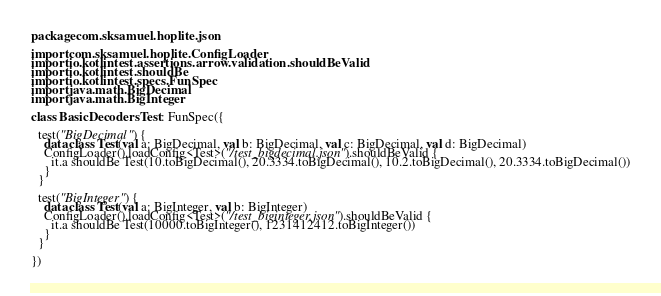Convert code to text. <code><loc_0><loc_0><loc_500><loc_500><_Kotlin_>package com.sksamuel.hoplite.json

import com.sksamuel.hoplite.ConfigLoader
import io.kotlintest.assertions.arrow.validation.shouldBeValid
import io.kotlintest.shouldBe
import io.kotlintest.specs.FunSpec
import java.math.BigDecimal
import java.math.BigInteger

class BasicDecodersTest : FunSpec({

  test("BigDecimal") {
    data class Test(val a: BigDecimal, val b: BigDecimal, val c: BigDecimal, val d: BigDecimal)
    ConfigLoader().loadConfig<Test>("/test_bigdecimal.json").shouldBeValid {
      it.a shouldBe Test(10.toBigDecimal(), 20.3334.toBigDecimal(), 10.2.toBigDecimal(), 20.3334.toBigDecimal())
    }
  }

  test("BigInteger") {
    data class Test(val a: BigInteger, val b: BigInteger)
    ConfigLoader().loadConfig<Test>("/test_biginteger.json").shouldBeValid {
      it.a shouldBe Test(10000.toBigInteger(), 1231412412.toBigInteger())
    }
  }

})</code> 